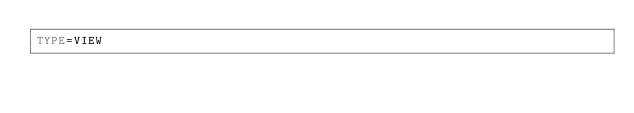<code> <loc_0><loc_0><loc_500><loc_500><_VisualBasic_>TYPE=VIEW</code> 